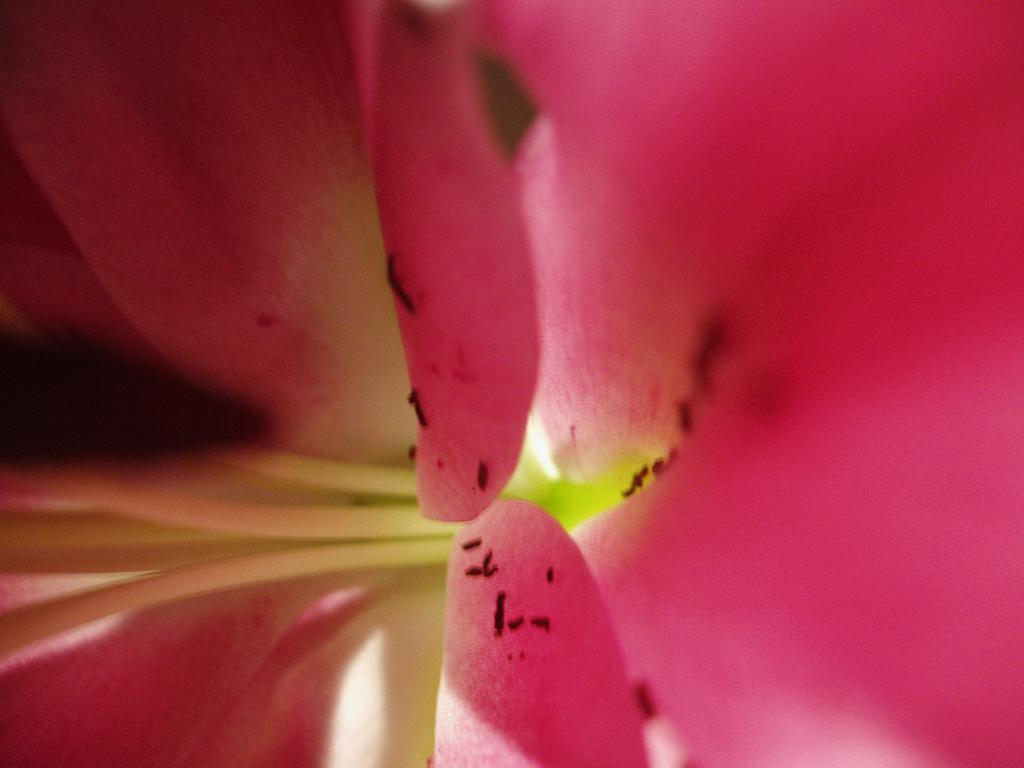What type of flower is in the image? There is a Lily flower in the image. What are the main features of the Lily flower? The Lily flower has petals. Can you touch the cap in the image? There is no cap present in the image; it only features a Lily flower. 